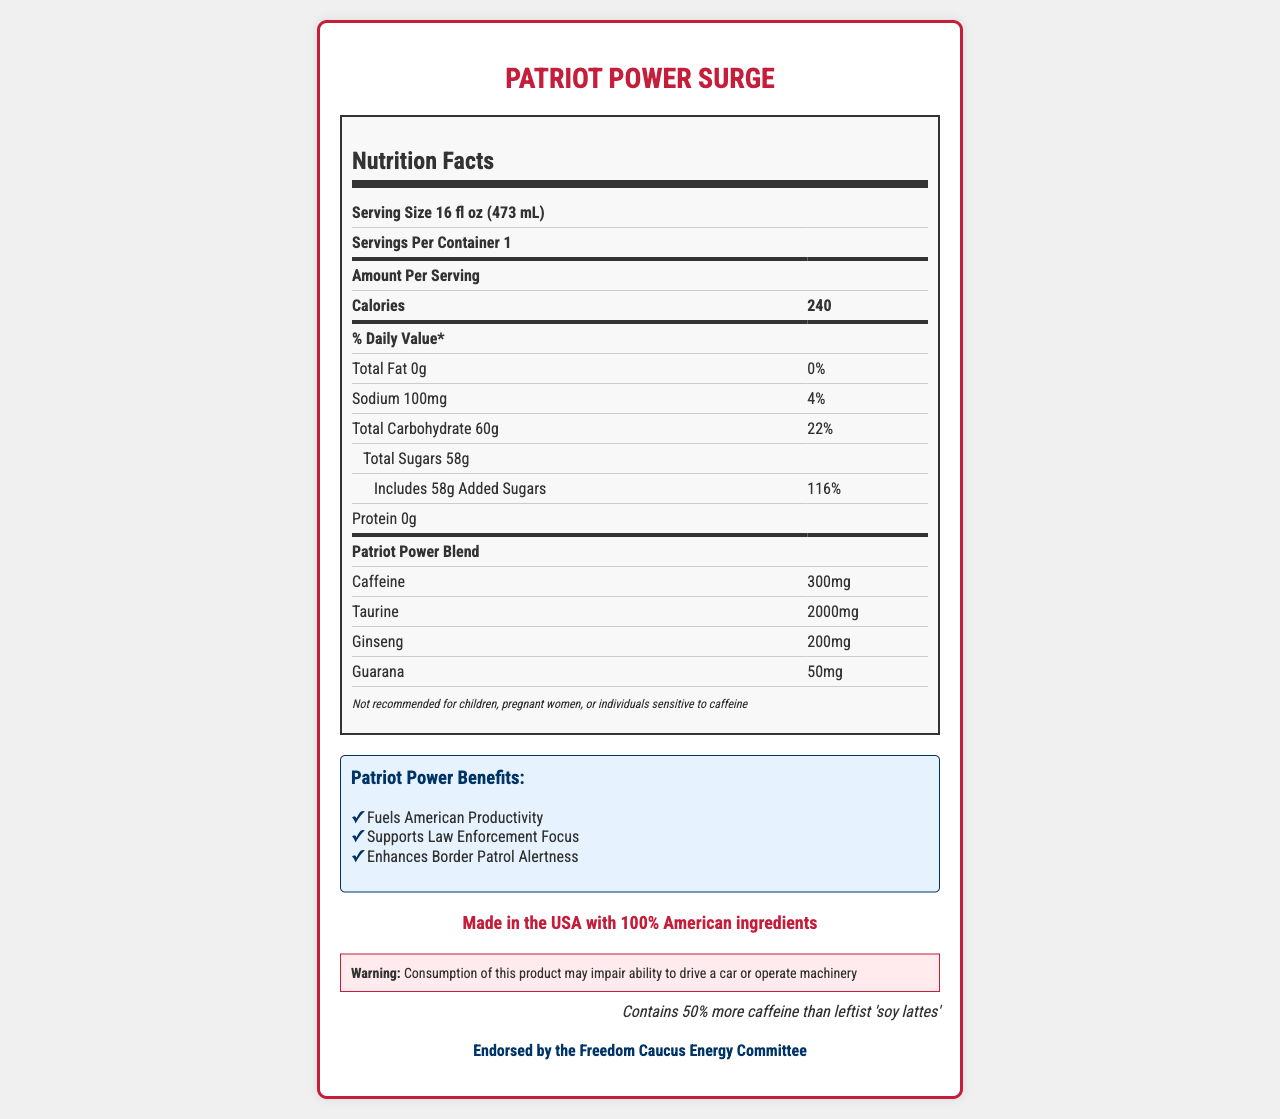what is the serving size of Patriot Power Surge? The serving size is explicitly mentioned in the document as "16 fl oz (473 mL)".
Answer: 16 fl oz (473 mL) how much caffeine does Patriot Power Surge contain per serving? The document lists the caffeine content as 300mg per serving.
Answer: 300mg how many calories are in a serving of Patriot Power Surge? The document states that there are 240 calories per serving.
Answer: 240 what is the percentage of daily value for added sugars? The document notes that the added sugars make up 116% of the daily value.
Answer: 116% does Patriot Power Surge contain any protein? The document specifies that the protein content is 0g.
Answer: No what are the three main marketing claims listed for Patriot Power Surge? The document lists these three claims under the "Patriot Power Benefits" section.
Answer: Fuels American Productivity, Supports Law Enforcement Focus, Enhances Border Patrol Alertness what are the main active ingredients in Patriot Power Surge besides caffeine? The active ingredients listed in addition to caffeine are Taurine (2000mg), Ginseng (200mg), and Guarana (50mg).
Answer: Taurine, Ginseng, Guarana which of the following is not an ingredient in Patriot Power Surge? A. High Fructose Corn Syrup B. Citric Acid C. Sucralose The document lists the ingredients, including High Fructose Corn Syrup and Citric Acid, but not Sucralose.
Answer: C. Sucralose how does the Patriot Power Surge compare to 'leftist soy lattes' in terms of caffeine content? A. 20% more caffeine B. 50% more caffeine C. 30% more caffeine The document includes a comparison stating that it contains "50% more caffeine than leftist 'soy lattes'".
Answer: B. 50% more caffeine should children or pregnant women consume Patriot Power Surge? The disclaimer in the document specifically states that it is not recommended for children or pregnant women.
Answer: No what is the political endorsement mentioned for Patriot Power Surge? The document mentions that it is endorsed by the Freedom Caucus Energy Committee.
Answer: Endorsed by the Freedom Caucus Energy Committee summarize the main idea of the document. The document showcases the nutritional facts, key ingredients, and various marketing and political endorsements, aiming to appeal to a conservative audience and highlight the product's benefits and high caffeine content.
Answer: The document provides detailed nutritional information about Patriot Power Surge, highlighting its high caffeine content and other ingredients. It emphasizes its benefits for productivity and alertness, appeals to conservative values, and includes various marketing claims and warnings. what is the precise amount of sodium per serving in Patriot Power Surge? The document specifies that the sodium content per serving is 100mg.
Answer: 100mg is natural flavors listed as one of the ingredients of Patriot Power Surge? The document lists natural flavors among the ingredients.
Answer: Yes are there any claims about the product affecting pregnancy? The document's disclaimer advises against consumption by pregnant women.
Answer: Yes how long has Patriot Power Surge been on the market? The document does not provide any information about how long the product has been on the market.
Answer: Cannot be determined 